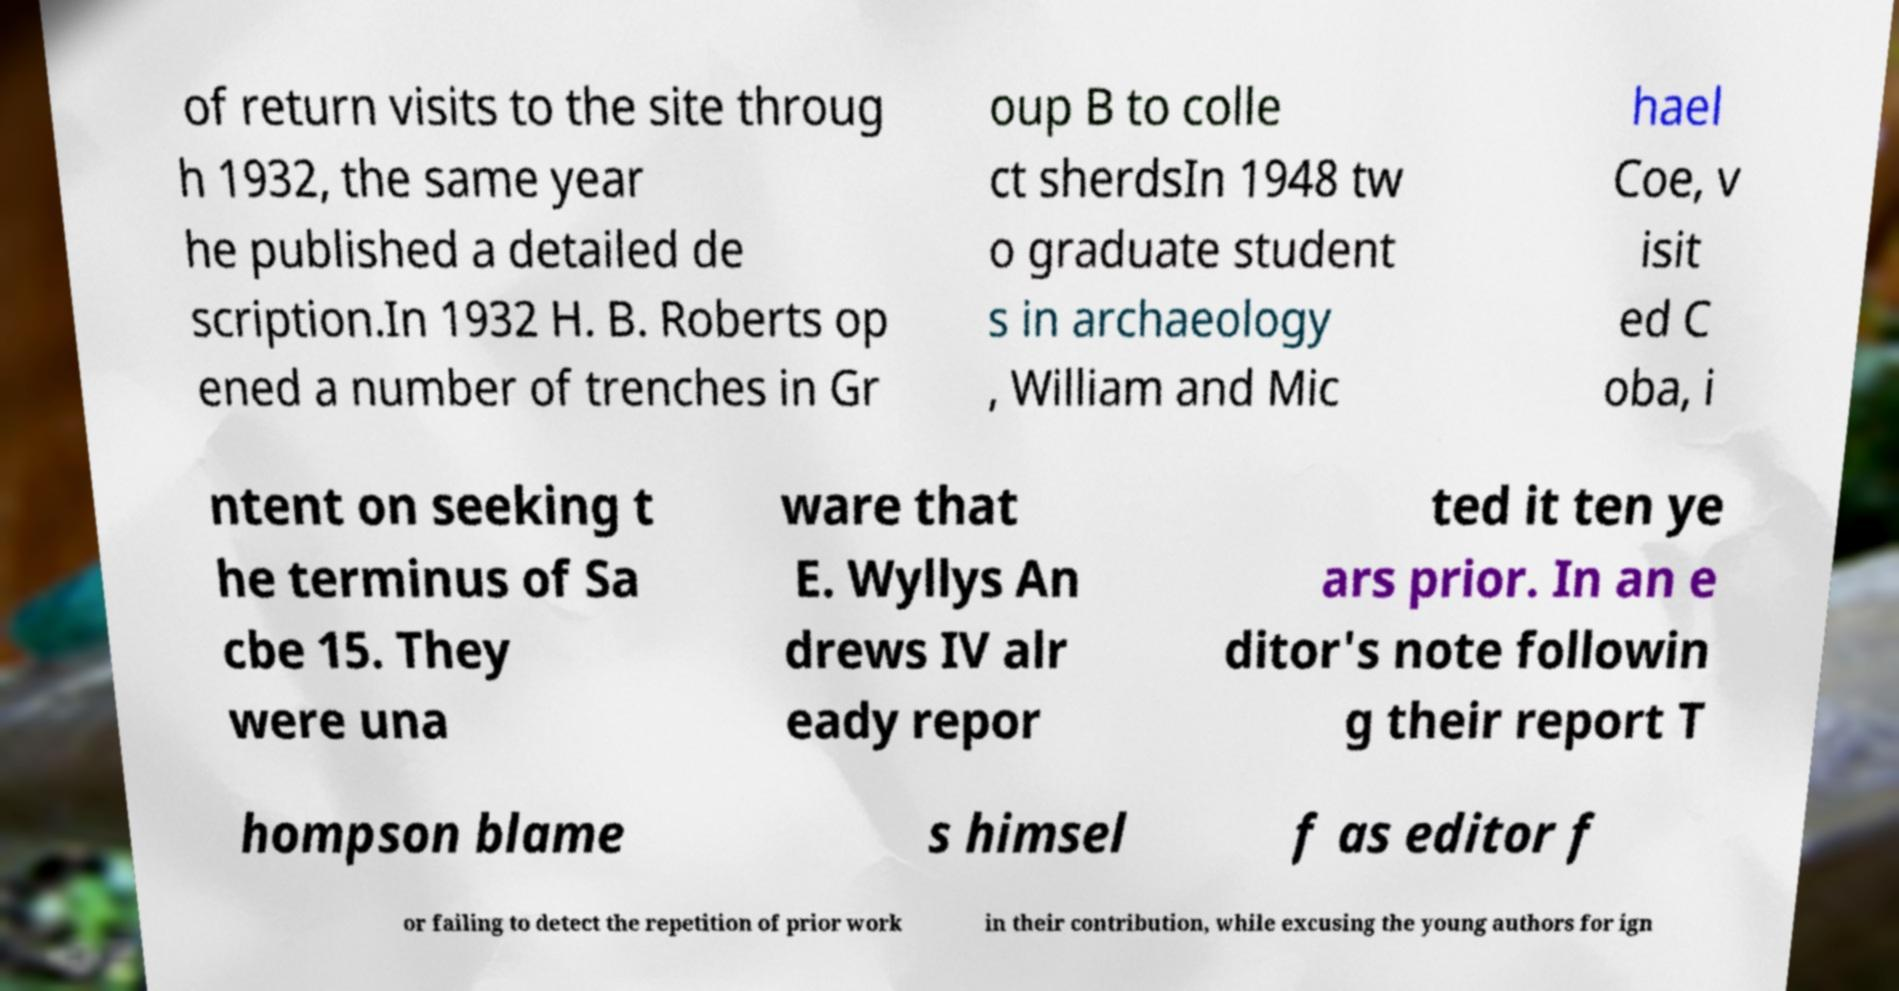Please read and relay the text visible in this image. What does it say? of return visits to the site throug h 1932, the same year he published a detailed de scription.In 1932 H. B. Roberts op ened a number of trenches in Gr oup B to colle ct sherdsIn 1948 tw o graduate student s in archaeology , William and Mic hael Coe, v isit ed C oba, i ntent on seeking t he terminus of Sa cbe 15. They were una ware that E. Wyllys An drews IV alr eady repor ted it ten ye ars prior. In an e ditor's note followin g their report T hompson blame s himsel f as editor f or failing to detect the repetition of prior work in their contribution, while excusing the young authors for ign 